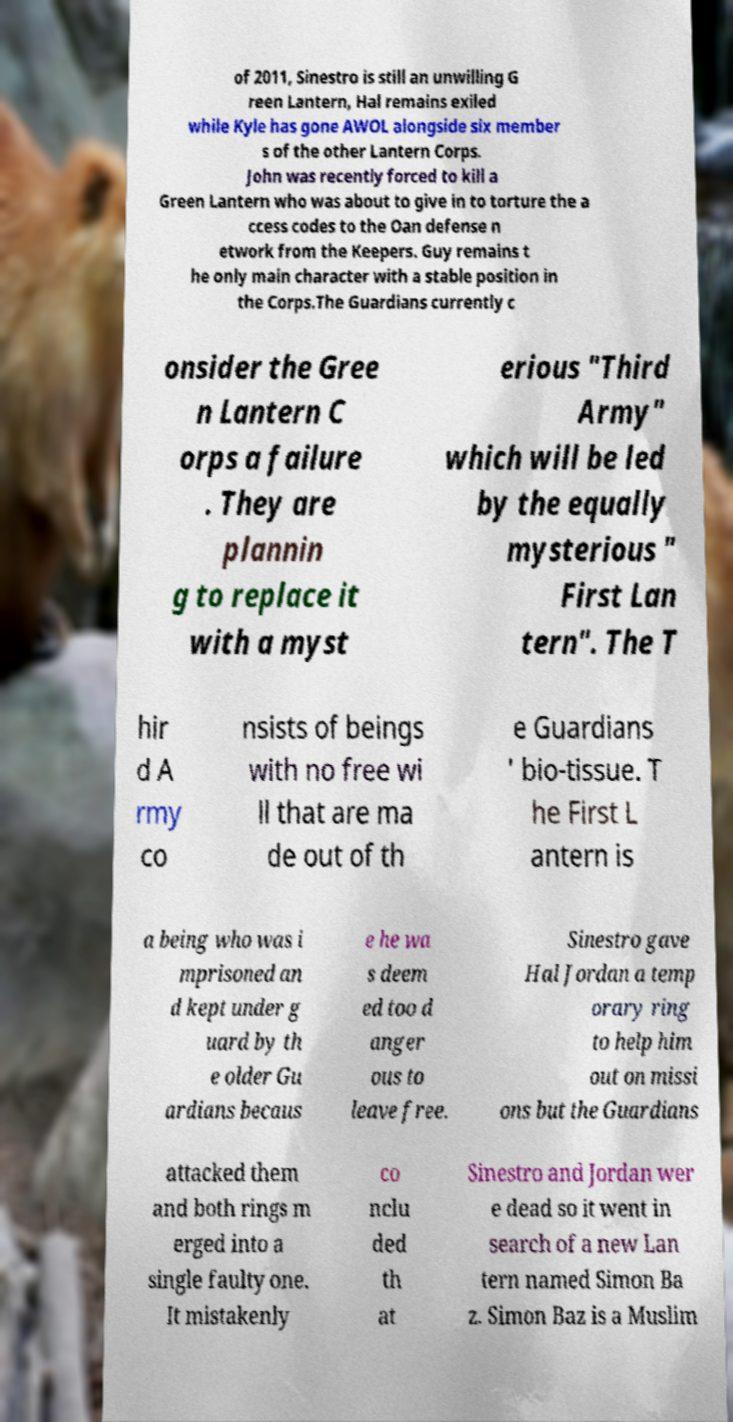Could you assist in decoding the text presented in this image and type it out clearly? of 2011, Sinestro is still an unwilling G reen Lantern, Hal remains exiled while Kyle has gone AWOL alongside six member s of the other Lantern Corps. John was recently forced to kill a Green Lantern who was about to give in to torture the a ccess codes to the Oan defense n etwork from the Keepers. Guy remains t he only main character with a stable position in the Corps.The Guardians currently c onsider the Gree n Lantern C orps a failure . They are plannin g to replace it with a myst erious "Third Army" which will be led by the equally mysterious " First Lan tern". The T hir d A rmy co nsists of beings with no free wi ll that are ma de out of th e Guardians ' bio-tissue. T he First L antern is a being who was i mprisoned an d kept under g uard by th e older Gu ardians becaus e he wa s deem ed too d anger ous to leave free. Sinestro gave Hal Jordan a temp orary ring to help him out on missi ons but the Guardians attacked them and both rings m erged into a single faulty one. It mistakenly co nclu ded th at Sinestro and Jordan wer e dead so it went in search of a new Lan tern named Simon Ba z. Simon Baz is a Muslim 